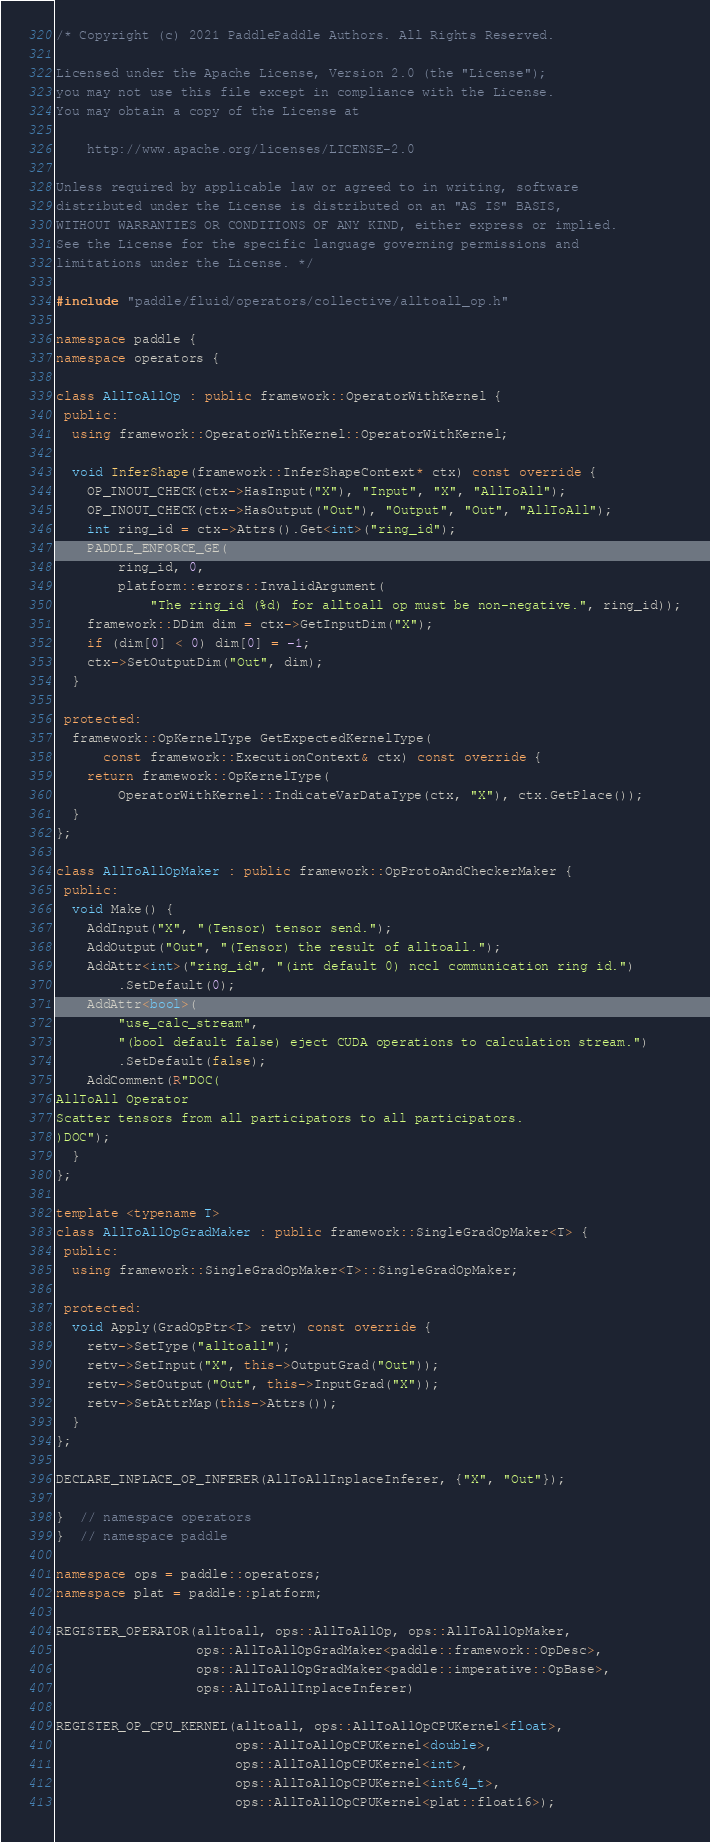<code> <loc_0><loc_0><loc_500><loc_500><_C++_>/* Copyright (c) 2021 PaddlePaddle Authors. All Rights Reserved.

Licensed under the Apache License, Version 2.0 (the "License");
you may not use this file except in compliance with the License.
You may obtain a copy of the License at

    http://www.apache.org/licenses/LICENSE-2.0

Unless required by applicable law or agreed to in writing, software
distributed under the License is distributed on an "AS IS" BASIS,
WITHOUT WARRANTIES OR CONDITIONS OF ANY KIND, either express or implied.
See the License for the specific language governing permissions and
limitations under the License. */

#include "paddle/fluid/operators/collective/alltoall_op.h"

namespace paddle {
namespace operators {

class AllToAllOp : public framework::OperatorWithKernel {
 public:
  using framework::OperatorWithKernel::OperatorWithKernel;

  void InferShape(framework::InferShapeContext* ctx) const override {
    OP_INOUT_CHECK(ctx->HasInput("X"), "Input", "X", "AllToAll");
    OP_INOUT_CHECK(ctx->HasOutput("Out"), "Output", "Out", "AllToAll");
    int ring_id = ctx->Attrs().Get<int>("ring_id");
    PADDLE_ENFORCE_GE(
        ring_id, 0,
        platform::errors::InvalidArgument(
            "The ring_id (%d) for alltoall op must be non-negative.", ring_id));
    framework::DDim dim = ctx->GetInputDim("X");
    if (dim[0] < 0) dim[0] = -1;
    ctx->SetOutputDim("Out", dim);
  }

 protected:
  framework::OpKernelType GetExpectedKernelType(
      const framework::ExecutionContext& ctx) const override {
    return framework::OpKernelType(
        OperatorWithKernel::IndicateVarDataType(ctx, "X"), ctx.GetPlace());
  }
};

class AllToAllOpMaker : public framework::OpProtoAndCheckerMaker {
 public:
  void Make() {
    AddInput("X", "(Tensor) tensor send.");
    AddOutput("Out", "(Tensor) the result of alltoall.");
    AddAttr<int>("ring_id", "(int default 0) nccl communication ring id.")
        .SetDefault(0);
    AddAttr<bool>(
        "use_calc_stream",
        "(bool default false) eject CUDA operations to calculation stream.")
        .SetDefault(false);
    AddComment(R"DOC(
AllToAll Operator
Scatter tensors from all participators to all participators.
)DOC");
  }
};

template <typename T>
class AllToAllOpGradMaker : public framework::SingleGradOpMaker<T> {
 public:
  using framework::SingleGradOpMaker<T>::SingleGradOpMaker;

 protected:
  void Apply(GradOpPtr<T> retv) const override {
    retv->SetType("alltoall");
    retv->SetInput("X", this->OutputGrad("Out"));
    retv->SetOutput("Out", this->InputGrad("X"));
    retv->SetAttrMap(this->Attrs());
  }
};

DECLARE_INPLACE_OP_INFERER(AllToAllInplaceInferer, {"X", "Out"});

}  // namespace operators
}  // namespace paddle

namespace ops = paddle::operators;
namespace plat = paddle::platform;

REGISTER_OPERATOR(alltoall, ops::AllToAllOp, ops::AllToAllOpMaker,
                  ops::AllToAllOpGradMaker<paddle::framework::OpDesc>,
                  ops::AllToAllOpGradMaker<paddle::imperative::OpBase>,
                  ops::AllToAllInplaceInferer)

REGISTER_OP_CPU_KERNEL(alltoall, ops::AllToAllOpCPUKernel<float>,
                       ops::AllToAllOpCPUKernel<double>,
                       ops::AllToAllOpCPUKernel<int>,
                       ops::AllToAllOpCPUKernel<int64_t>,
                       ops::AllToAllOpCPUKernel<plat::float16>);
</code> 